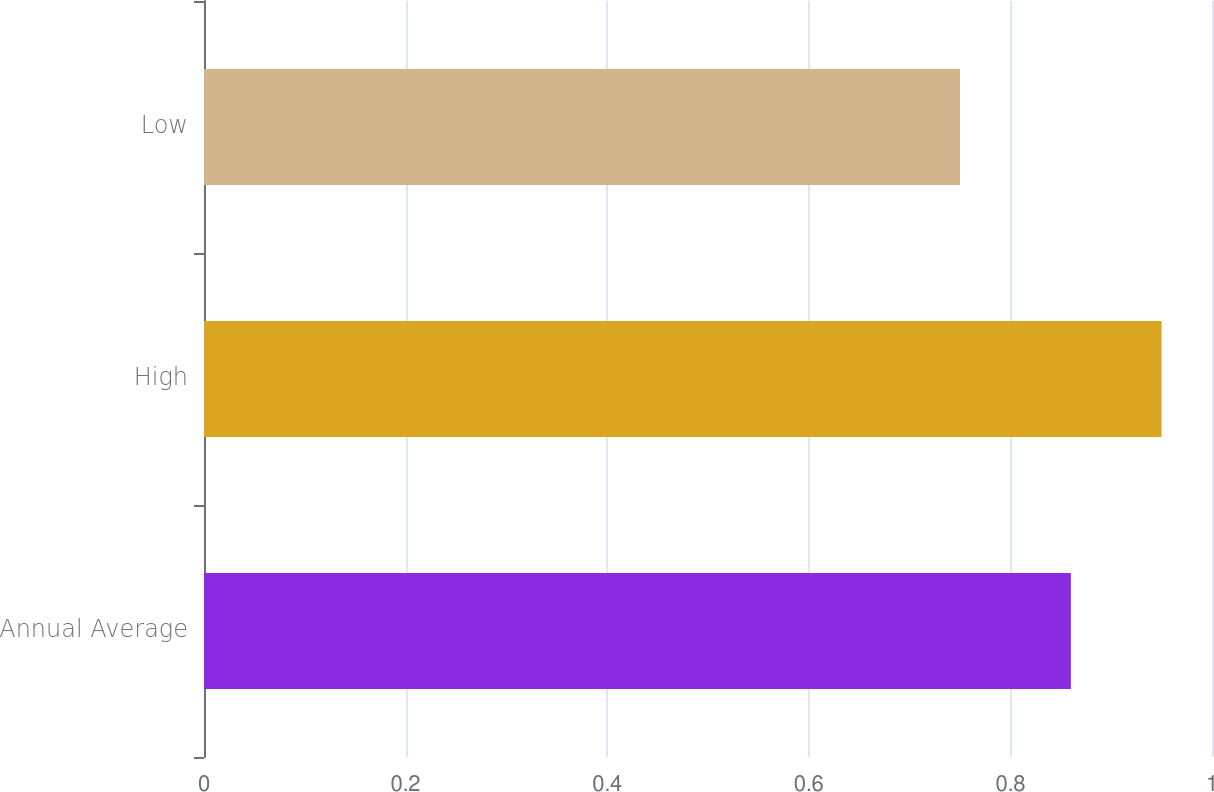<chart> <loc_0><loc_0><loc_500><loc_500><bar_chart><fcel>Annual Average<fcel>High<fcel>Low<nl><fcel>0.86<fcel>0.95<fcel>0.75<nl></chart> 